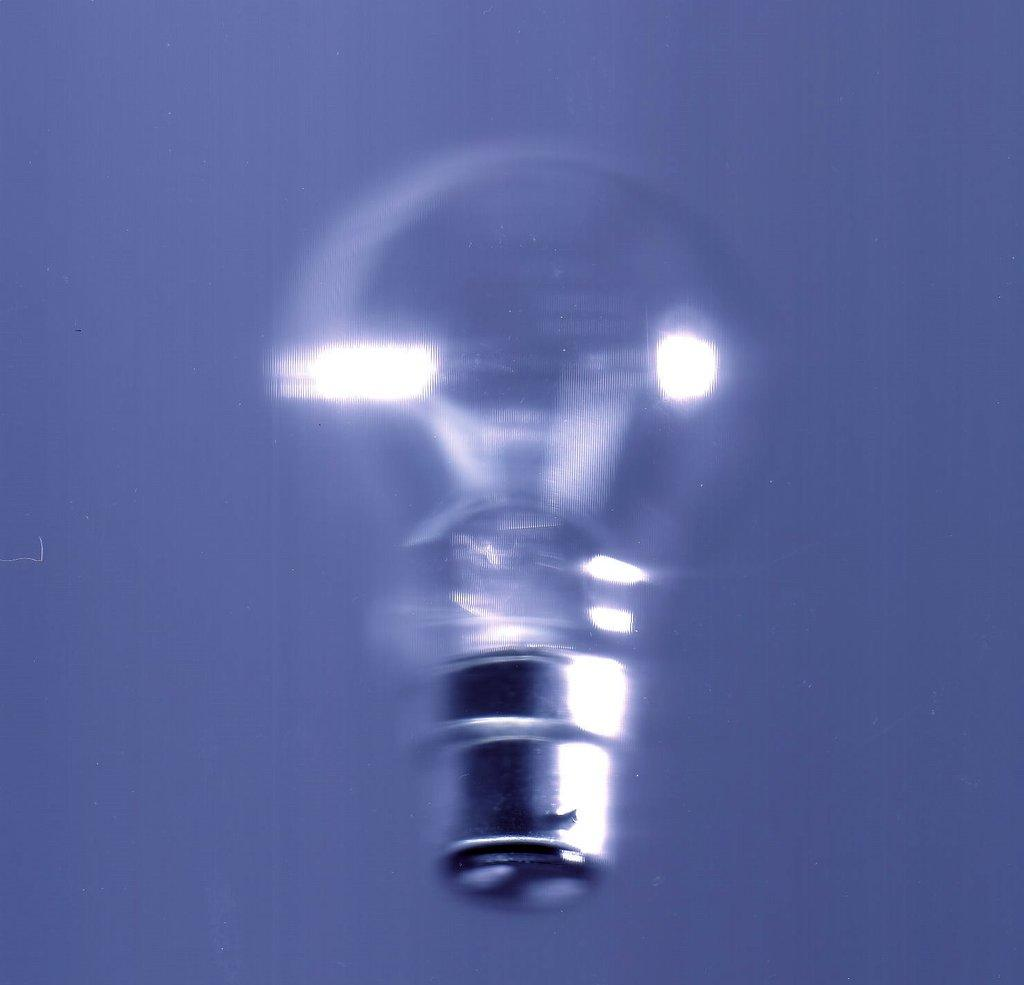What is the main object in the center of the image? There is a glass bulb in the middle of the image. What type of star can be seen driving a soap-covered car in the image? There is no star, driving, or soap-covered car present in the image; it only features a glass bulb. 